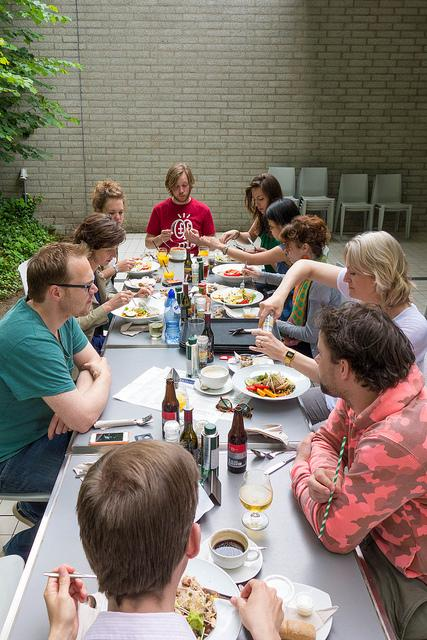Why does the person with the green shirt have no food? Please explain your reasoning. is sharing. They are all eating together. 